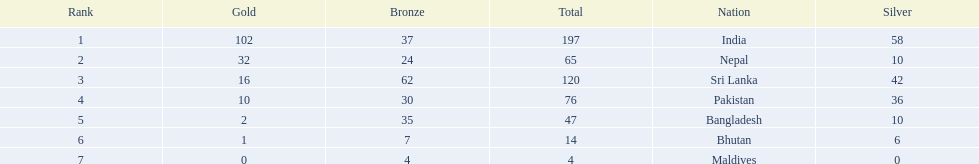What are all the countries listed in the table? India, Nepal, Sri Lanka, Pakistan, Bangladesh, Bhutan, Maldives. Which of these is not india? Nepal, Sri Lanka, Pakistan, Bangladesh, Bhutan, Maldives. Of these, which is first? Nepal. 